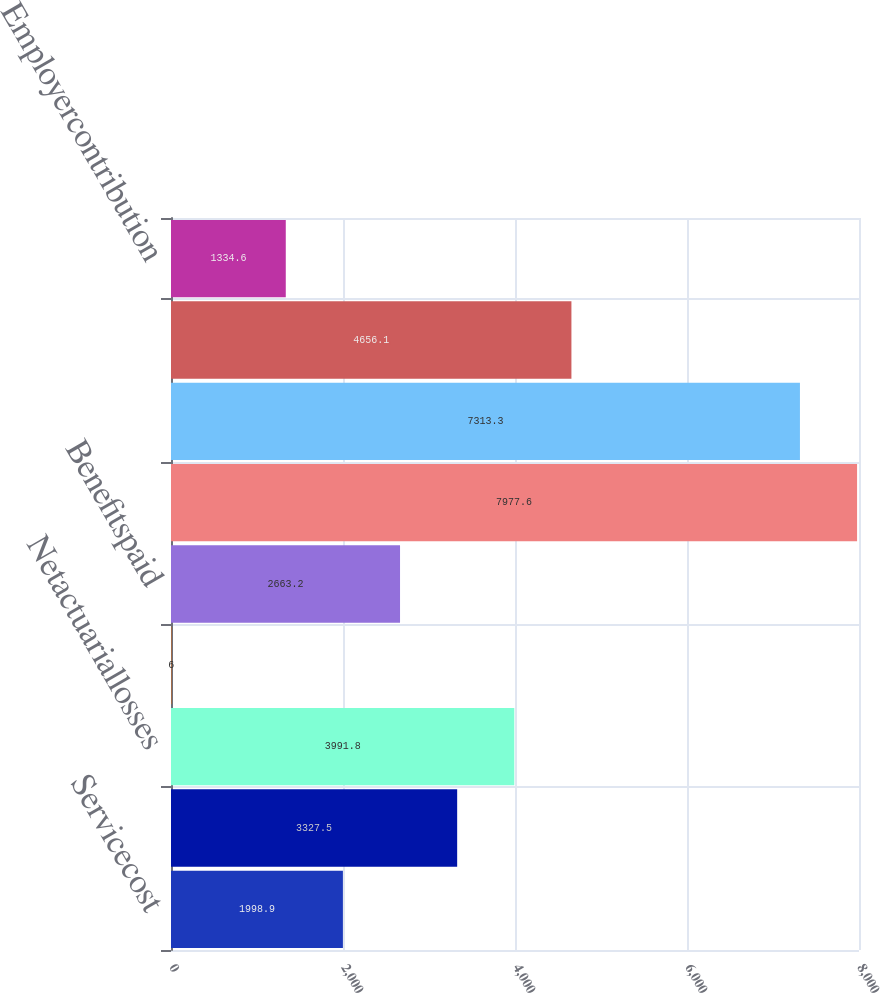<chart> <loc_0><loc_0><loc_500><loc_500><bar_chart><fcel>Servicecost<fcel>Interestcost<fcel>Netactuariallosses<fcel>Changeinbenefits<fcel>Benefitspaid<fcel>Benefitobligationatendofyear<fcel>Unnamed: 6<fcel>Actualreturnonplanassets<fcel>Employercontribution<nl><fcel>1998.9<fcel>3327.5<fcel>3991.8<fcel>6<fcel>2663.2<fcel>7977.6<fcel>7313.3<fcel>4656.1<fcel>1334.6<nl></chart> 